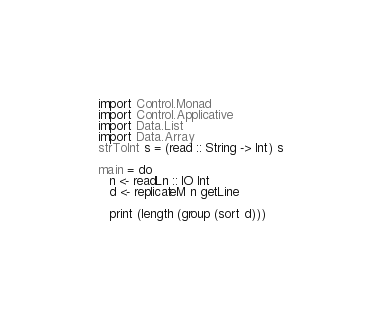<code> <loc_0><loc_0><loc_500><loc_500><_Haskell_>import Control.Monad
import Control.Applicative
import Data.List
import Data.Array
strToInt s = (read :: String -> Int) s

main = do
   n <- readLn :: IO Int
   d <- replicateM n getLine
   
   print (length (group (sort d)))</code> 